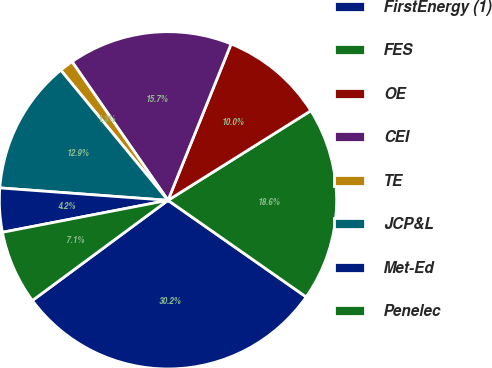Convert chart to OTSL. <chart><loc_0><loc_0><loc_500><loc_500><pie_chart><fcel>FirstEnergy (1)<fcel>FES<fcel>OE<fcel>CEI<fcel>TE<fcel>JCP&L<fcel>Met-Ed<fcel>Penelec<nl><fcel>30.16%<fcel>18.63%<fcel>9.98%<fcel>15.74%<fcel>1.33%<fcel>12.86%<fcel>4.21%<fcel>7.09%<nl></chart> 